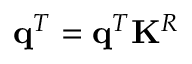Convert formula to latex. <formula><loc_0><loc_0><loc_500><loc_500>q ^ { T } = q ^ { T } K ^ { R }</formula> 